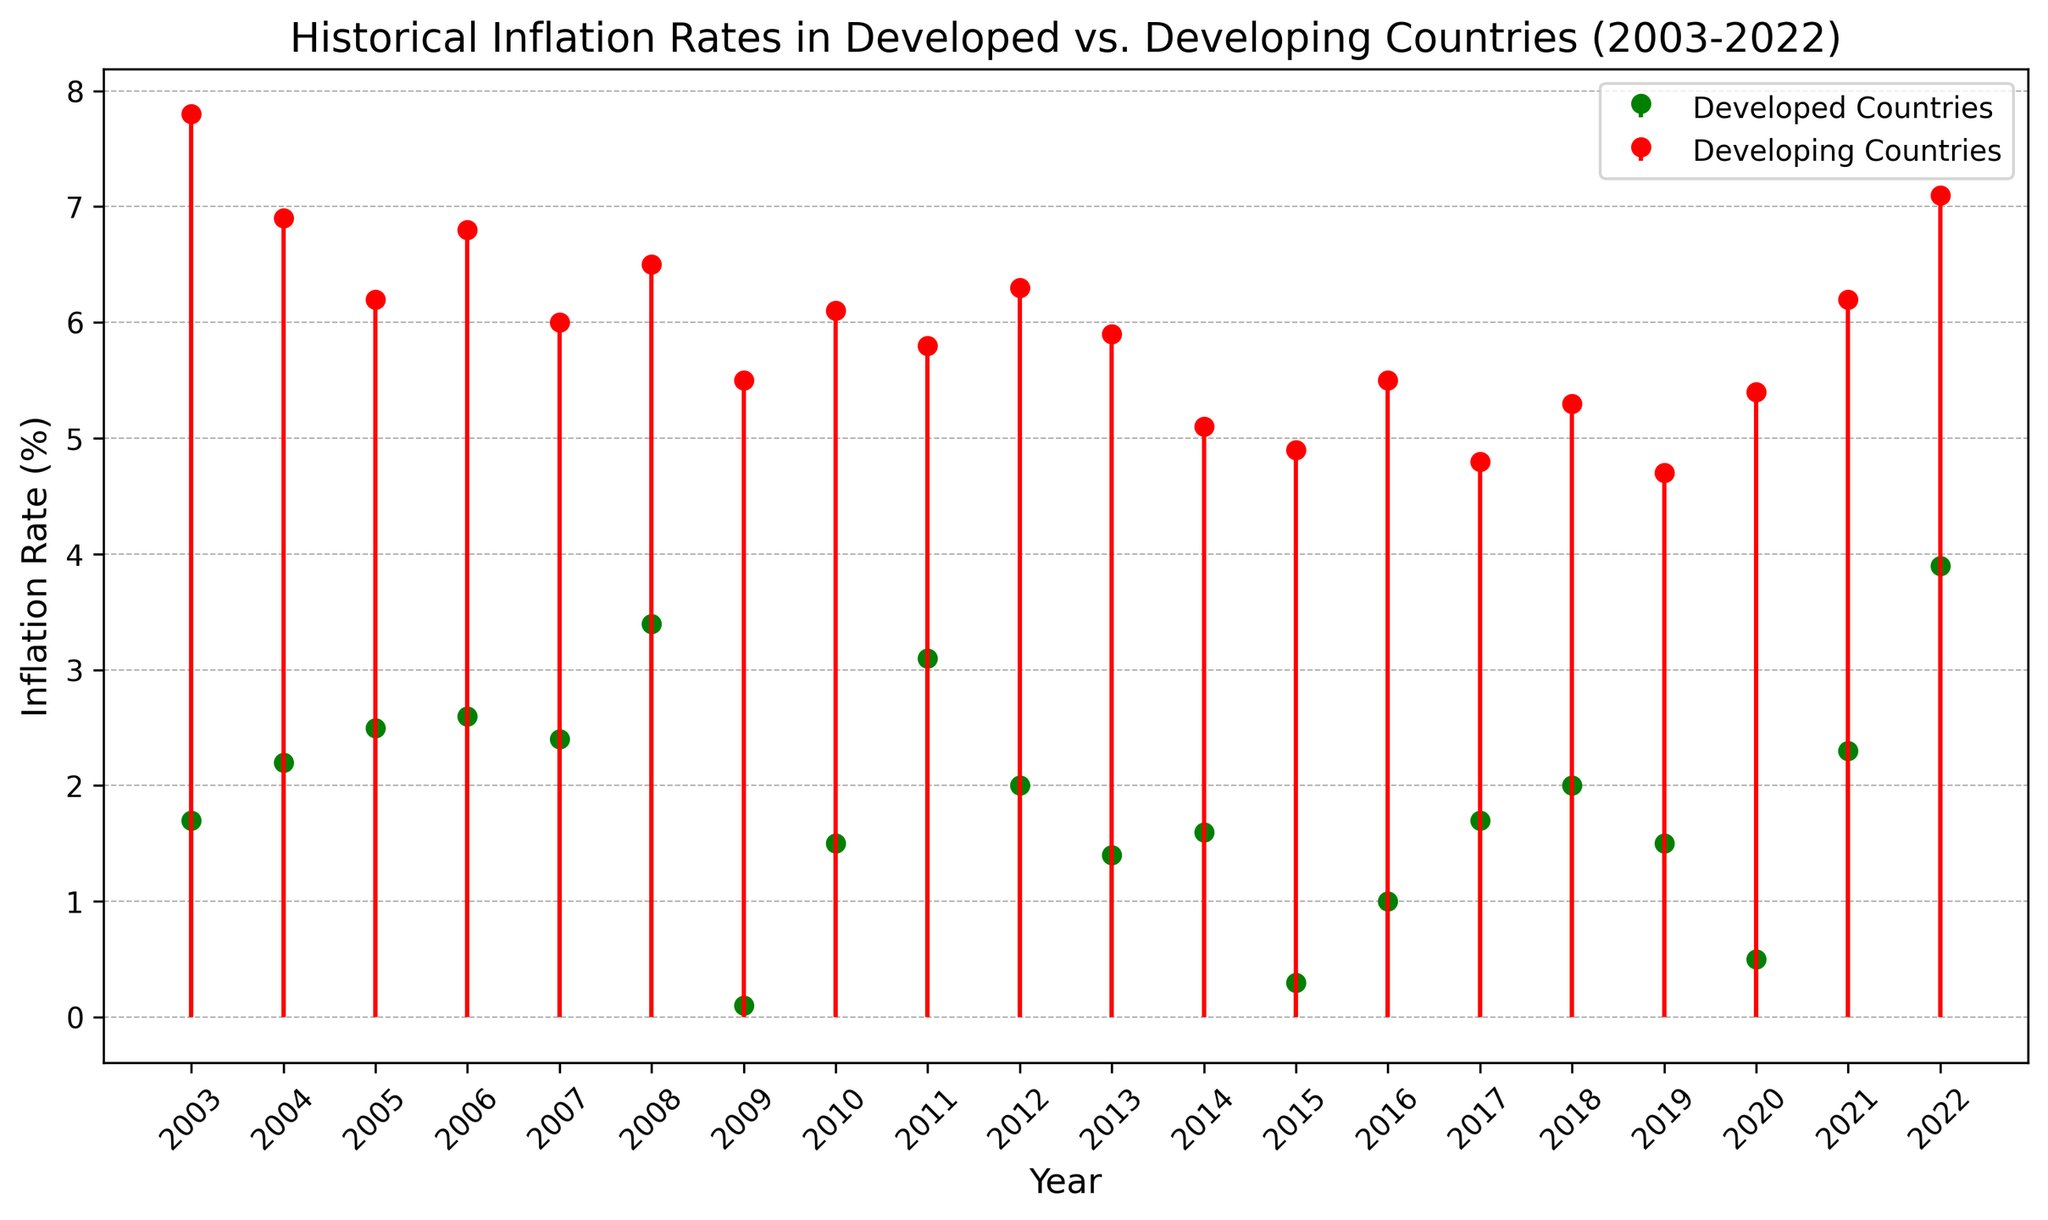Which country type had the highest inflation rate in 2008? By looking at the stem plot, we compare the inflation rates of both country types in 2008. Developing countries had an inflation rate of 6.5%, while developed countries had 3.4%. Therefore, developing countries had the highest rate.
Answer: Developing countries How did the inflation rates in developed countries compare between 2015 and 2016? In the stem plot, the inflation rate for developed countries in 2015 is 0.3%, and in 2016 it is 1.0%. Comparing these values shows that the inflation rate in developed countries increased from 2015 to 2016.
Answer: Increased Which year had the largest difference in inflation rates between developed and developing countries? To find the year with the largest difference, we need to calculate the difference for each year. 2003 has a difference of 7.8 - 1.7 = 6.1%, 2004: 6.9 - 2.2 = 4.7%, and so on. The largest difference is in 2003, which is 6.1%.
Answer: 2003 What's the average inflation rate in developed countries over the entire period? Sum the inflation rates for developed countries over all years and divide by the number of years. The sum is 1.7 + 2.2 + 2.5 + 2.6 + 2.4 + 3.4 + 0.1 + 1.5 + 3.1 + 2.0 + 1.4 + 1.6 + 0.3 + 1.0 + 1.7 + 2.0 + 1.5 + 0.5 + 2.3 + 3.9 = 39.7. The period covers 20 years, so the average is 39.7 / 20 = 1.985.
Answer: 1.985% In which year did both country types have the smallest difference in inflation rates, and what was the difference? For each year, calculate the absolute difference and identify the smallest one. For instance, 2003 has 7.8 - 1.7 = 6.1%, 2004 has 6.9 - 2.2 = 4.7%, and so on. The smallest difference is in 2017 with 4.8 - 1.7 = 3.1%.
Answer: 2017, 3.1% Which country type had a consistent increase in inflation rates from 2015 to 2018? Observe and note the inflation rates for both types from 2015 to 2018. Developed countries: 0.3%, 1.0%, 1.7%, 2.0% (consistent increase). Developing countries: 4.9%, 5.5%, 4.8%, 5.3% (fluctuates). Therefore, developed countries had a consistent increase.
Answer: Developed countries Which country type had a higher inflation rate on more occasions during the 20-year period? Count the number of years each country type had a higher inflation rate. Developed countries had higher rates in 0 years, while developing countries had higher rates in all 20 years.
Answer: Developing countries What is the median inflation rate for developing countries? List the inflation rates for developing countries and find the middle value. The values are: 7.8, 6.9, 6.2, 6.8, 6.0, 6.5, 5.5, 6.1, 5.8, 6.3, 5.9, 5.1, 4.9, 5.5, 4.8, 5.3, 4.7, 5.4, 6.2, 7.1. The median (middle) value in a list of 20 values is the average of the 10th and 11th values: (5.9 + 5.8) / 2 = 5.85.
Answer: 5.85 How did the inflation rate trend differ between developed and developing countries from 2009 to 2010? Compare the inflation rates for 2009 and 2010. For developed countries: 0.1% (2009) to 1.5% (2010), which is an increase. For developing countries: 5.5% (2009) to 6.1% (2010), which is also an increase. Both trends show an increase, but developed countries had a more significant increase.
Answer: Both increased, more significant in developed What trend do you observe in the inflation rates of developed and developing countries from 2020 to 2022? Examine the inflation rates for developed and developing countries in 2020, 2021, and 2022. Developed: 0.5%, 2.3%, 3.9% (upward trend). Developing: 5.4%, 6.2%, 7.1% (upward trend). Both country types show an upward trend in inflation rates.
Answer: Upward trend 